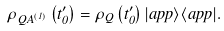Convert formula to latex. <formula><loc_0><loc_0><loc_500><loc_500>\rho _ { Q A ^ { \left ( 1 \right ) } } \left ( t _ { 0 } ^ { \prime } \right ) = \rho _ { Q } \left ( t _ { 0 } ^ { \prime } \right ) | a p p \rangle \langle a p p | .</formula> 